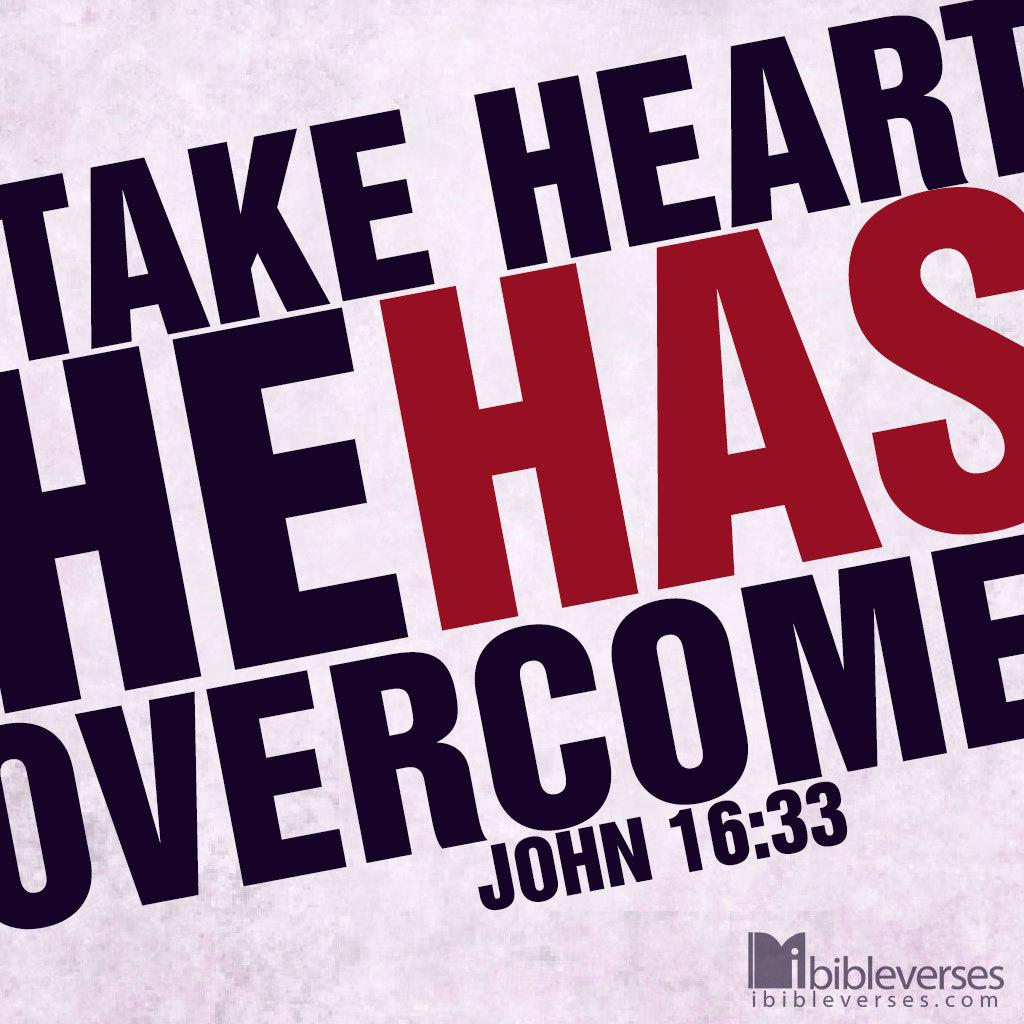<image>
Share a concise interpretation of the image provided. A bible verse from John 16:33 is provided by ibibleverses.com 